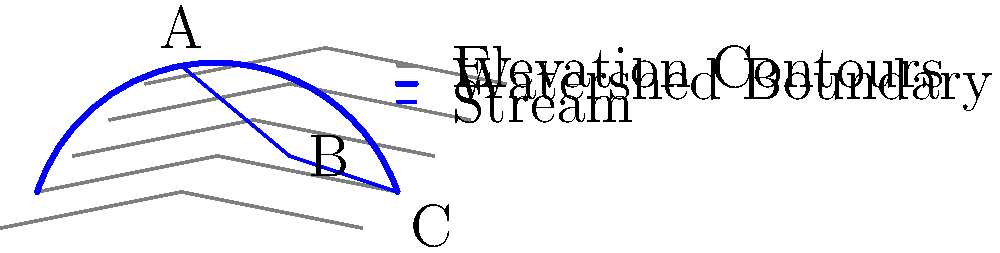Using the topographic map and GIS data provided, analyze the watershed delineation shown. What is the primary factor influencing the shape of this watershed, and how does it affect the flow direction of the main stream from point A to point C? To analyze the watershed delineation and understand the primary factor influencing its shape, we need to follow these steps:

1. Observe the contour lines: The contour lines represent elevation, with closer spacing indicating steeper slopes and wider spacing indicating gentler slopes.

2. Identify the watershed boundary: The blue line represents the watershed boundary, which follows the ridgeline or highest points surrounding the drainage area.

3. Locate the main stream: The blue line from point A to C represents the main stream within the watershed.

4. Analyze the topography:
   a. The contour lines show a valley-like formation with higher elevations on both sides of the stream.
   b. The watershed boundary follows the highest points around this valley.

5. Determine the primary factor influencing the watershed shape:
   The primary factor is the topography, specifically the ridge lines and valley formation. The watershed boundary is determined by the highest points surrounding the drainage area, which creates a roughly oval shape in this case.

6. Analyze the flow direction:
   a. The stream flows from point A (highest elevation) to point C (lowest elevation).
   b. The flow direction is influenced by gravity, following the path of steepest descent.
   c. The stream's course is determined by the valley's shape, created by the surrounding topography.

7. Effect on flow direction:
   The topography channels the water flow from the higher elevations at the edges of the watershed towards the center and then downstream. This creates a dendritic drainage pattern, with smaller tributaries (not shown) likely joining the main stream as it flows from A to C.

In conclusion, the primary factor influencing the watershed shape is the topography, specifically the ridge lines and valley formation. This topography affects the flow direction by channeling water from higher elevations at the watershed boundaries towards the central stream, which then flows from point A to C following the path of steepest descent through the valley.
Answer: Topography; channels flow from high elevations at watershed edges to central stream, following steepest descent. 